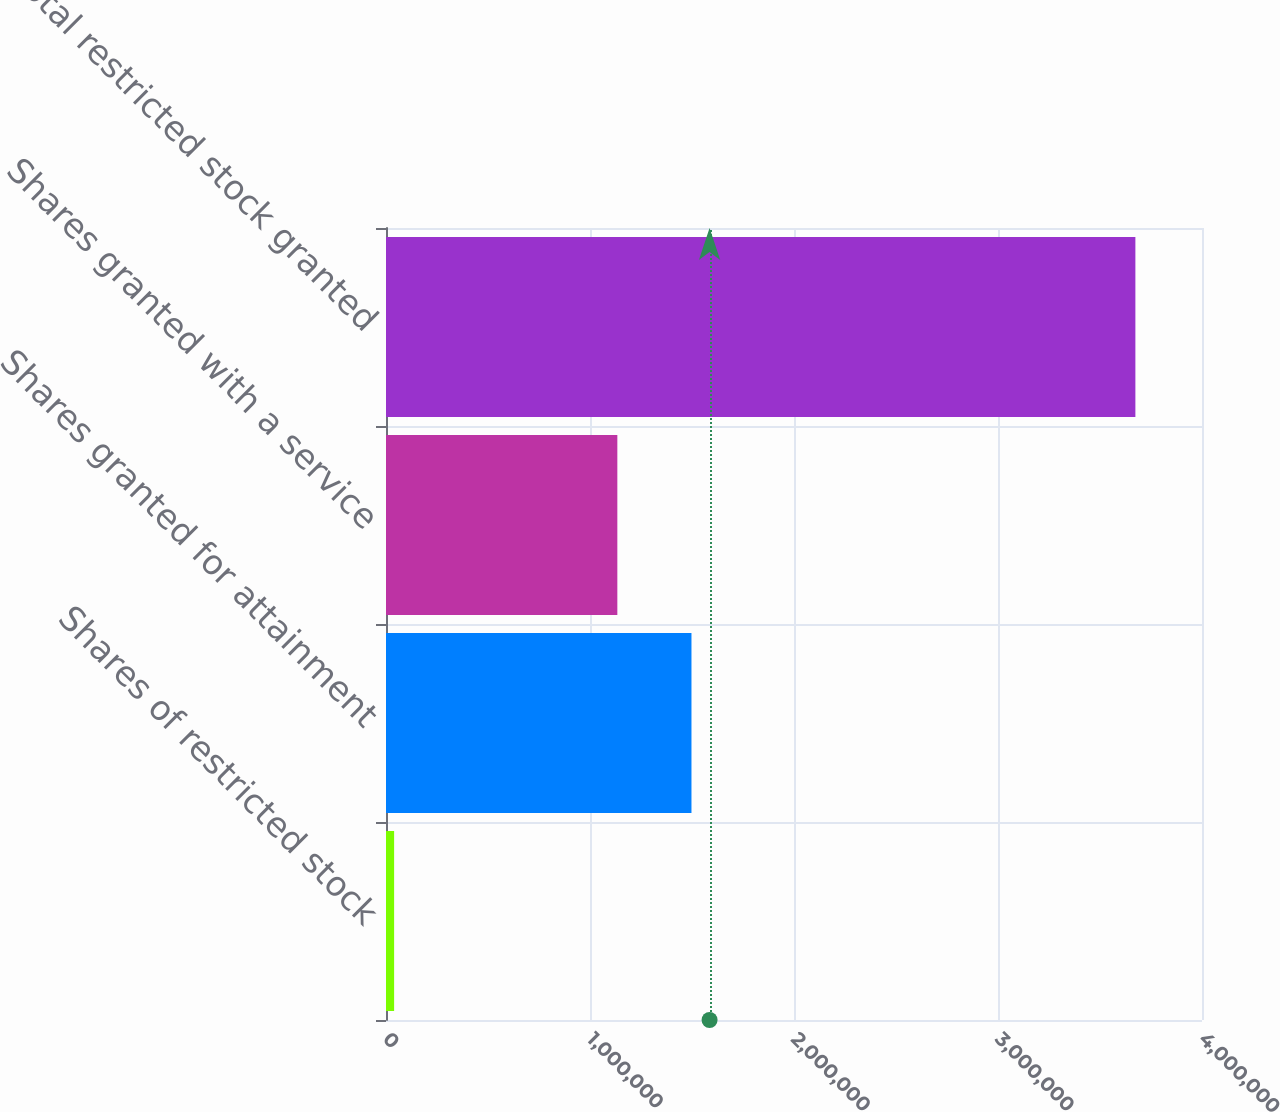Convert chart. <chart><loc_0><loc_0><loc_500><loc_500><bar_chart><fcel>Shares of restricted stock<fcel>Shares granted for attainment<fcel>Shares granted with a service<fcel>Total restricted stock granted<nl><fcel>39792<fcel>1.4974e+06<fcel>1.13403e+06<fcel>3.67344e+06<nl></chart> 